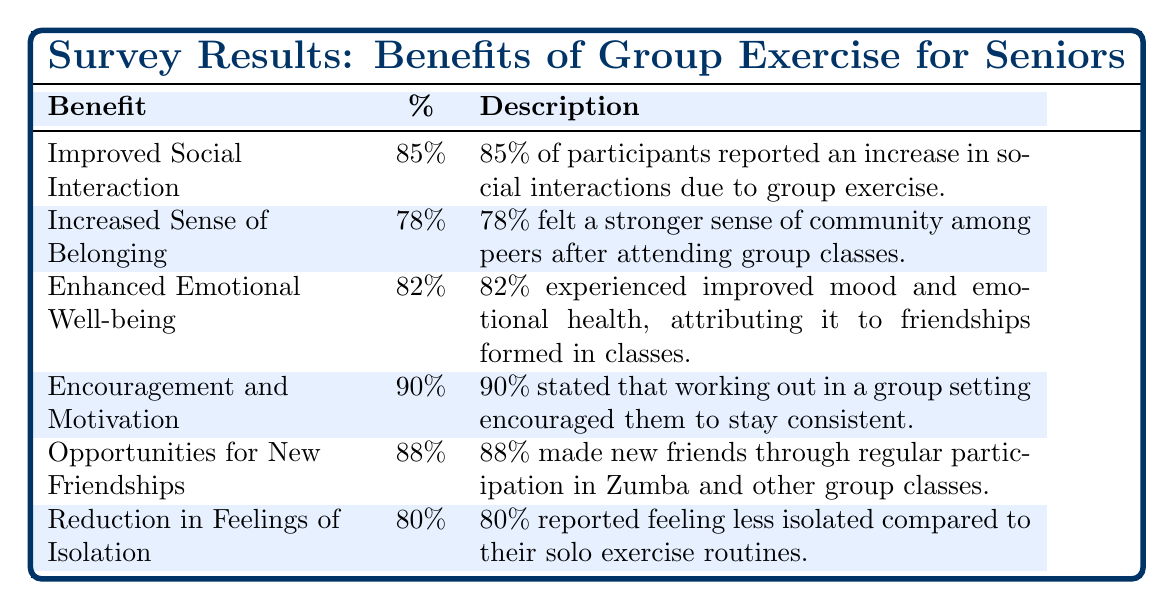What is the percentage of participants who felt encouraged to stay consistent due to the group setting? The table shows that 90% of participants stated that working out in a group setting encouraged them to stay consistent.
Answer: 90% How many benefits have a percentage of 80% or higher? There are 5 benefits with percentages of 80% or higher: Improved Social Interaction (85%), Enhanced Emotional Well-being (82%), Encouragement and Motivation (90%), Opportunities for New Friendships (88%), and Reduction in Feelings of Isolation (80%). This totals to 5 benefits.
Answer: 5 Is it true that more participants reported a reduction in feelings of isolation than an increased sense of belonging? The table indicates that 80% reported a reduction in feelings of isolation, while 78% felt an increased sense of belonging. Since 80% is greater than 78%, the statement is true.
Answer: Yes What is the average percentage of all listed benefits in the survey? To calculate the average, sum all the percentages: 85 + 78 + 82 + 90 + 88 + 80 = 513. There are 6 benefits, so divide the total by 6. The average is 513 / 6 = 85.5.
Answer: 85.5 What benefit had the highest reported percentage, and what was that percentage? Looking at the table, the benefit with the highest percentage is "Encouragement and Motivation" at 90%.
Answer: 90% 